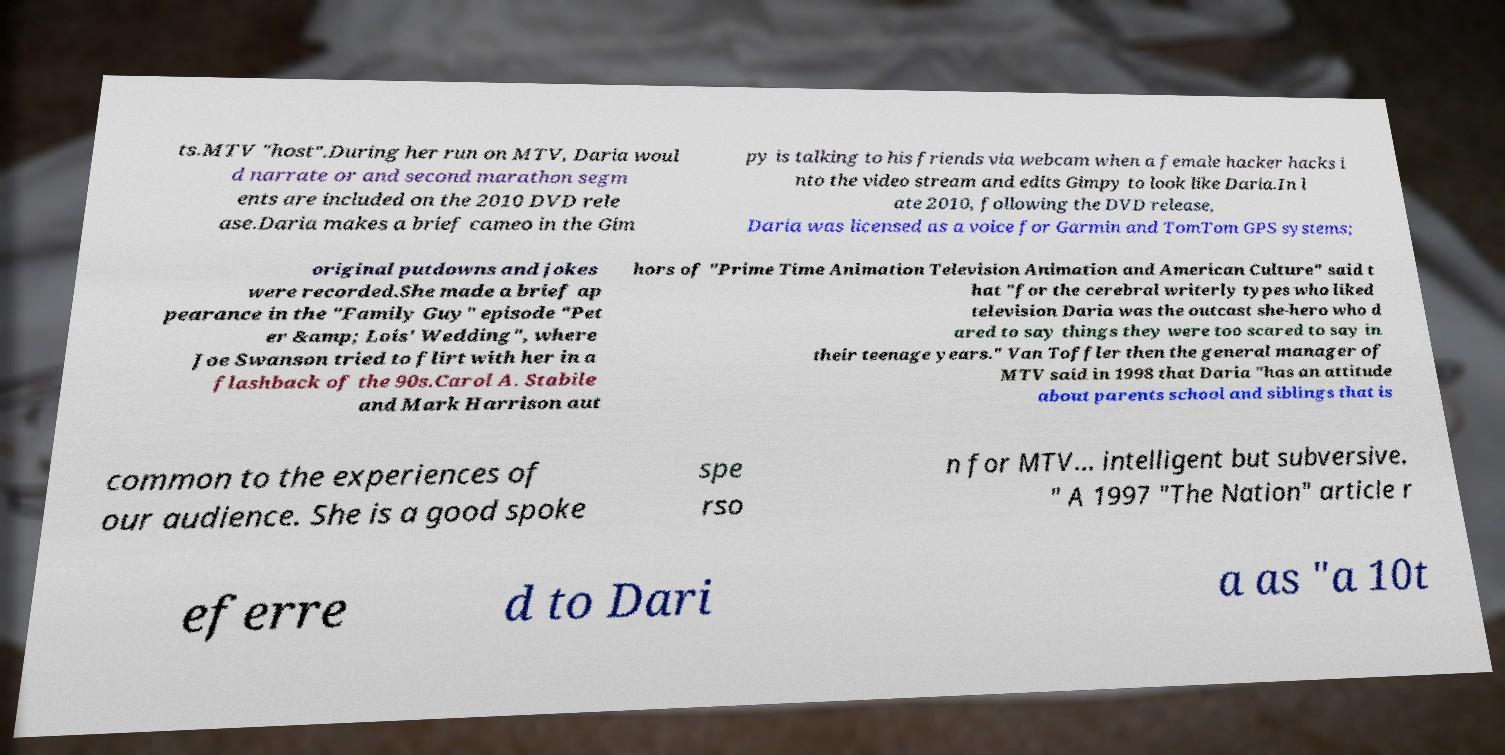Please identify and transcribe the text found in this image. ts.MTV "host".During her run on MTV, Daria woul d narrate or and second marathon segm ents are included on the 2010 DVD rele ase.Daria makes a brief cameo in the Gim py is talking to his friends via webcam when a female hacker hacks i nto the video stream and edits Gimpy to look like Daria.In l ate 2010, following the DVD release, Daria was licensed as a voice for Garmin and TomTom GPS systems; original putdowns and jokes were recorded.She made a brief ap pearance in the "Family Guy" episode "Pet er &amp; Lois' Wedding", where Joe Swanson tried to flirt with her in a flashback of the 90s.Carol A. Stabile and Mark Harrison aut hors of "Prime Time Animation Television Animation and American Culture" said t hat "for the cerebral writerly types who liked television Daria was the outcast she-hero who d ared to say things they were too scared to say in their teenage years." Van Toffler then the general manager of MTV said in 1998 that Daria "has an attitude about parents school and siblings that is common to the experiences of our audience. She is a good spoke spe rso n for MTV... intelligent but subversive. " A 1997 "The Nation" article r eferre d to Dari a as "a 10t 